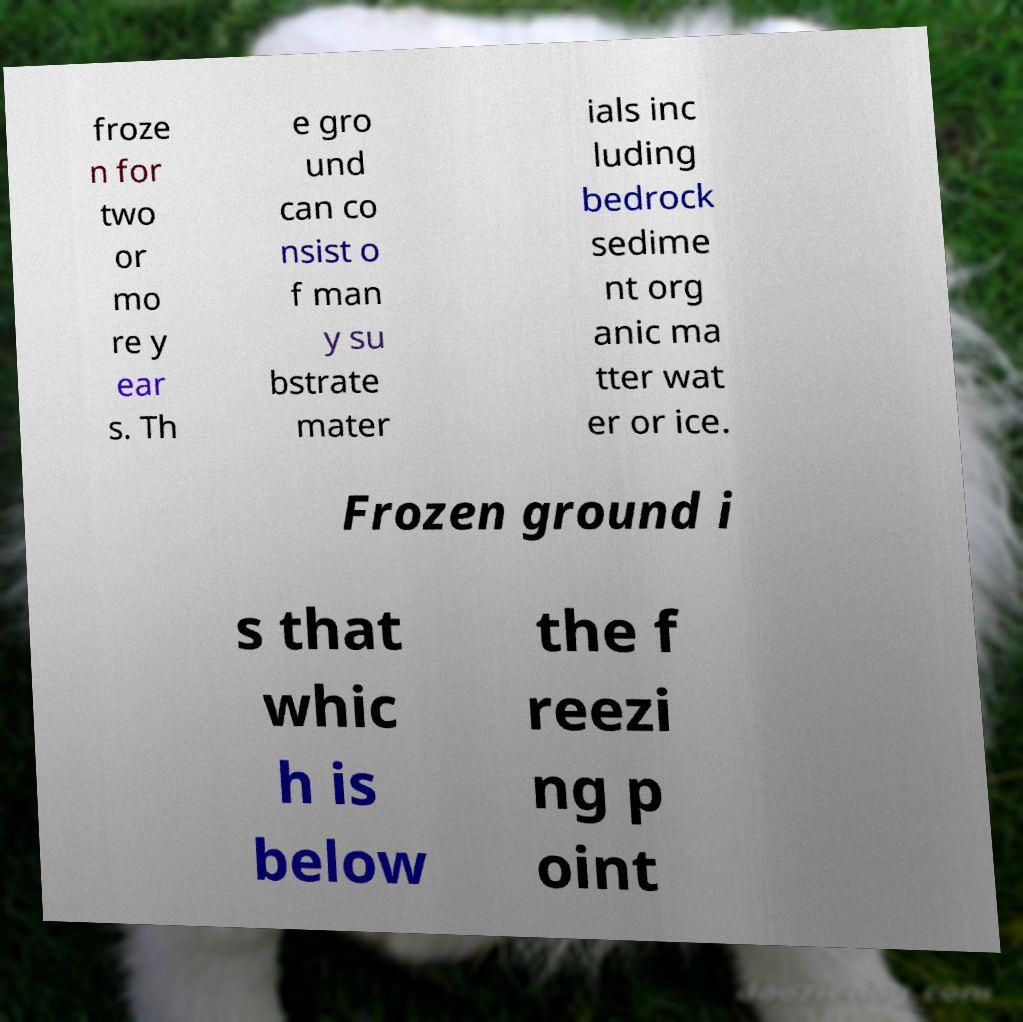I need the written content from this picture converted into text. Can you do that? froze n for two or mo re y ear s. Th e gro und can co nsist o f man y su bstrate mater ials inc luding bedrock sedime nt org anic ma tter wat er or ice. Frozen ground i s that whic h is below the f reezi ng p oint 